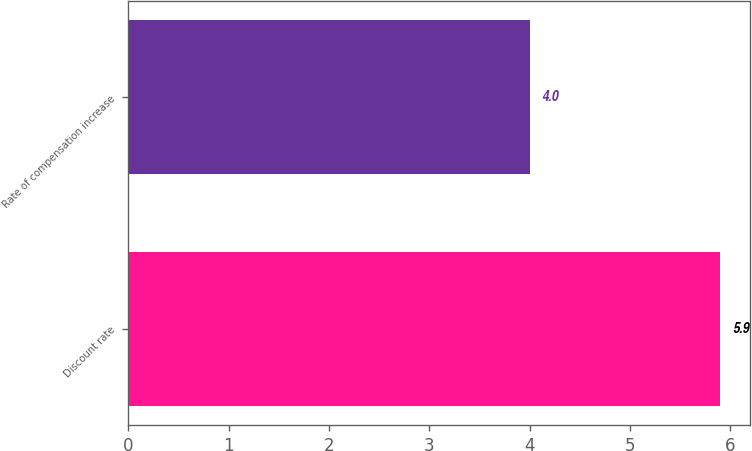Convert chart. <chart><loc_0><loc_0><loc_500><loc_500><bar_chart><fcel>Discount rate<fcel>Rate of compensation increase<nl><fcel>5.9<fcel>4<nl></chart> 